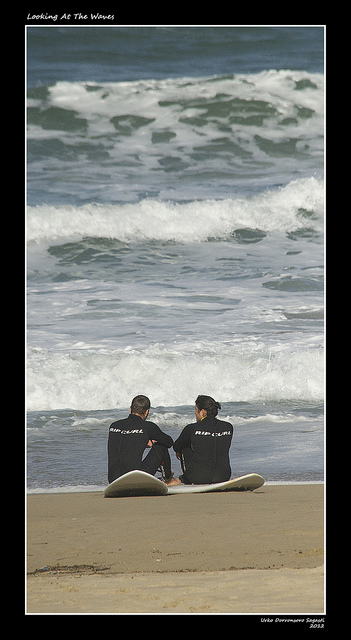What is the time of day in the image? Based on the shadows and light, the photo was likely taken either in the morning or late afternoon, times that are often favored by surfers for their typically better wave conditions. 